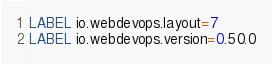<code> <loc_0><loc_0><loc_500><loc_500><_Dockerfile_>LABEL io.webdevops.layout=7
LABEL io.webdevops.version=0.50.0
</code> 